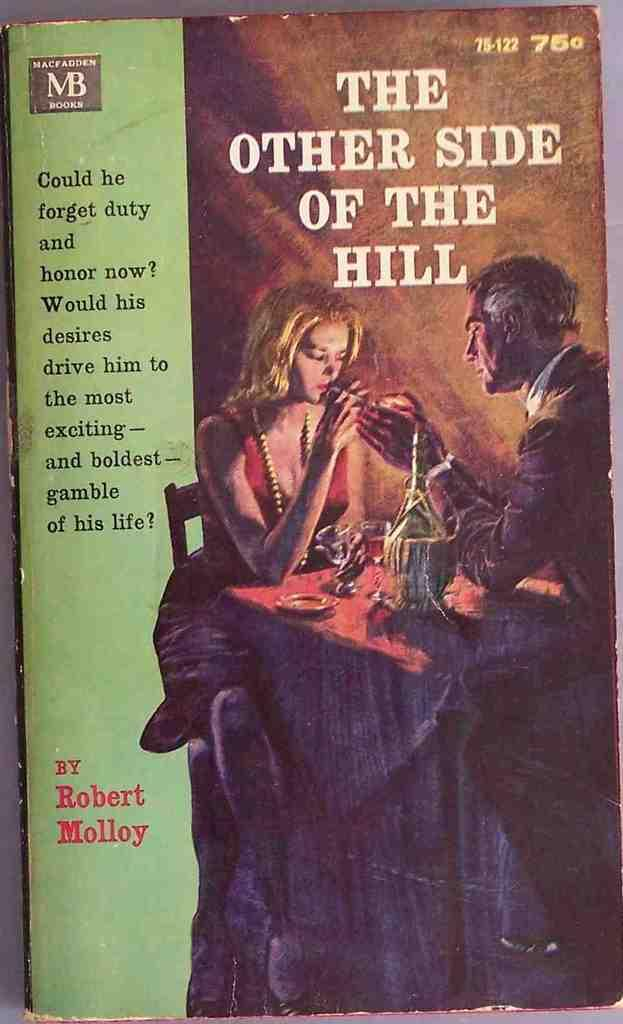<image>
Describe the image concisely. A copy of the book "The other side of the hill" written by Robert Molloy. 